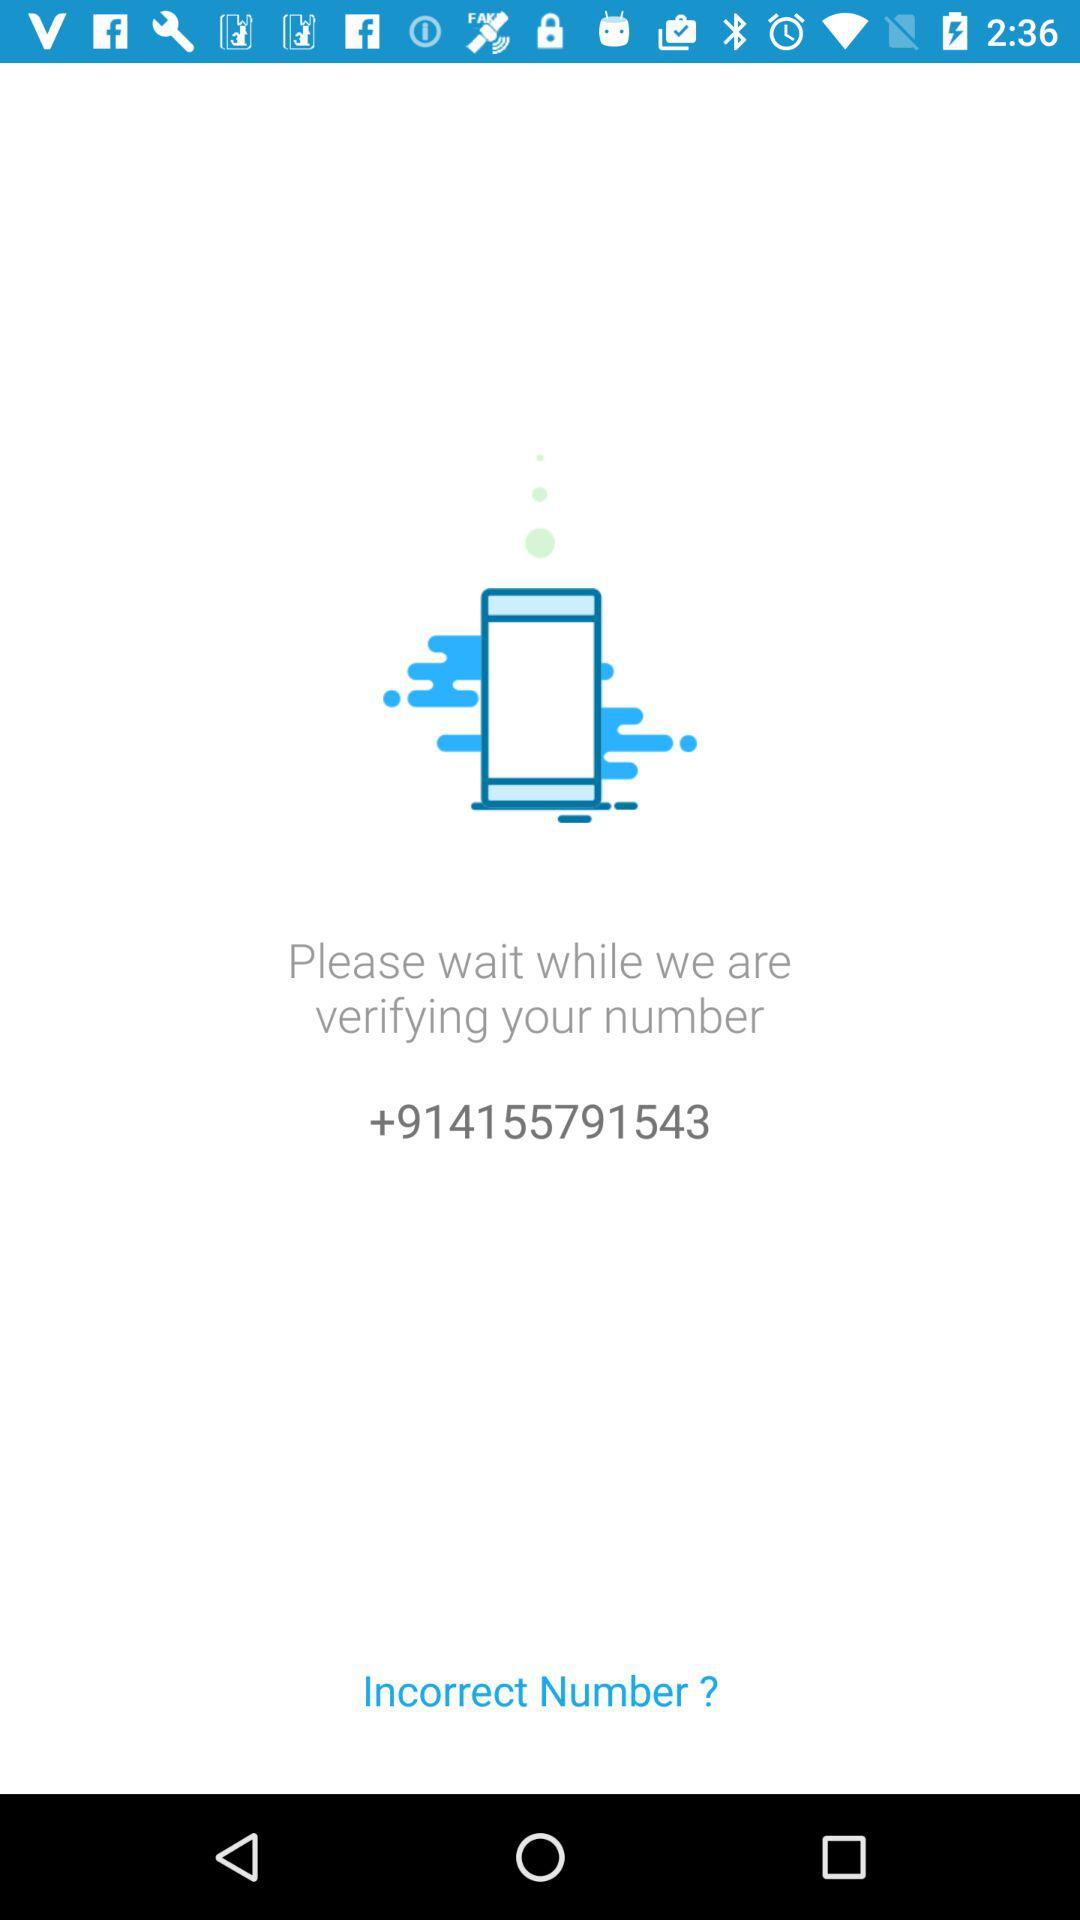What is the phone number? The phone number is +914155791543. 